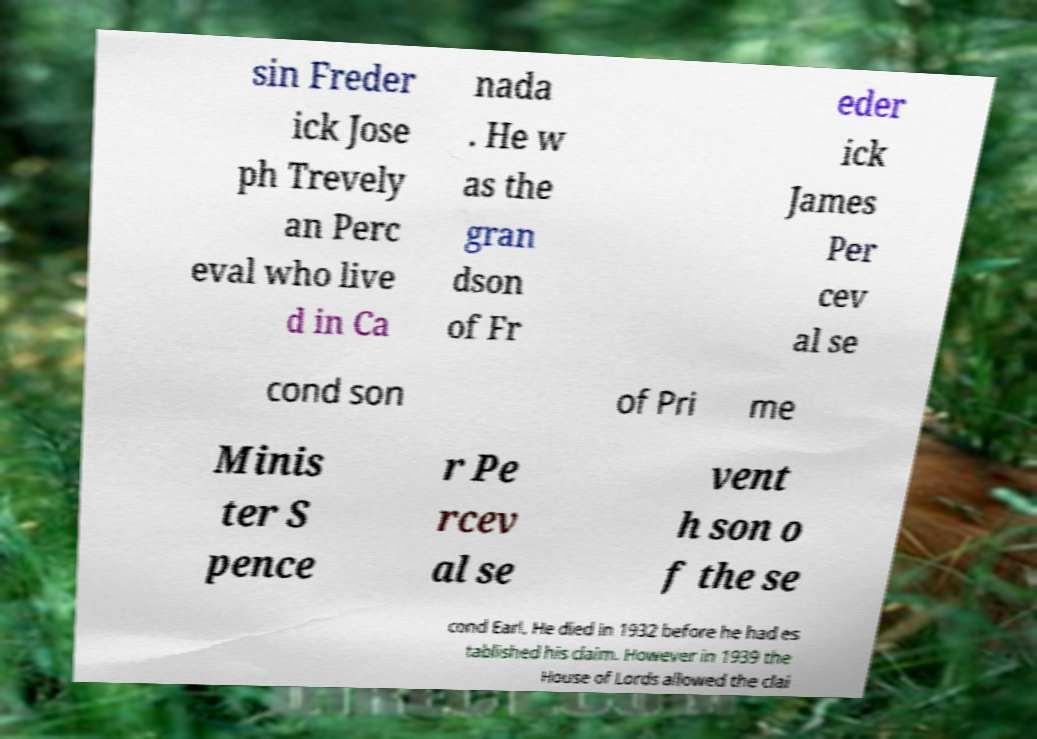Please read and relay the text visible in this image. What does it say? sin Freder ick Jose ph Trevely an Perc eval who live d in Ca nada . He w as the gran dson of Fr eder ick James Per cev al se cond son of Pri me Minis ter S pence r Pe rcev al se vent h son o f the se cond Earl. He died in 1932 before he had es tablished his claim. However in 1939 the House of Lords allowed the clai 